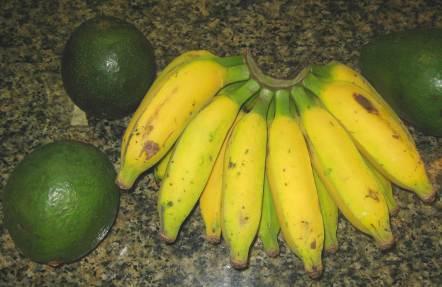What food is shown?
Quick response, please. Banana. How many fruits are here?
Be succinct. 2. What location grows these food items?
Give a very brief answer. Tropics. What is the green items?
Answer briefly. Limes. How many bananas are sitting on the counter?
Give a very brief answer. 11. 